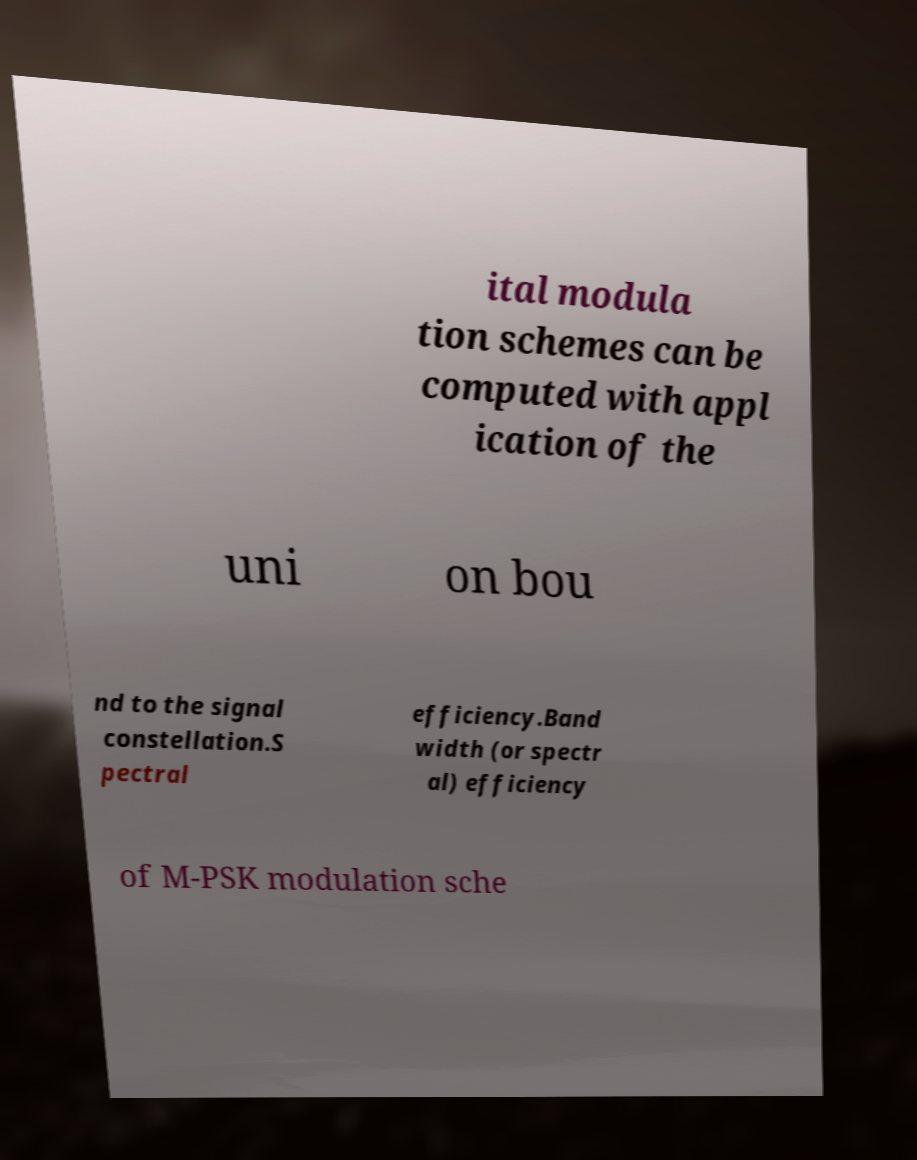Please identify and transcribe the text found in this image. ital modula tion schemes can be computed with appl ication of the uni on bou nd to the signal constellation.S pectral efficiency.Band width (or spectr al) efficiency of M-PSK modulation sche 